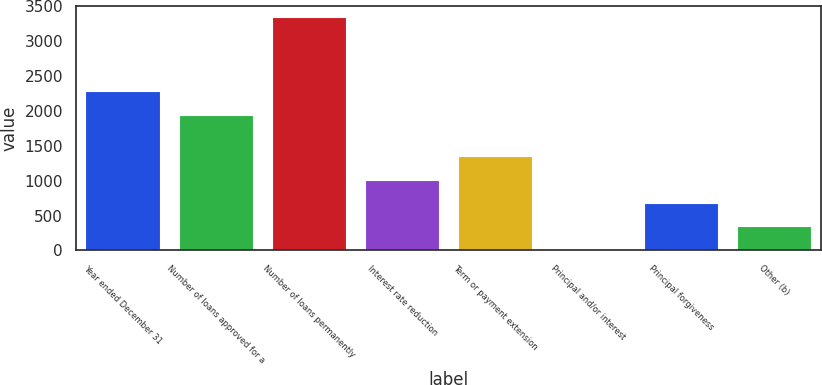<chart> <loc_0><loc_0><loc_500><loc_500><bar_chart><fcel>Year ended December 31<fcel>Number of loans approved for a<fcel>Number of loans permanently<fcel>Interest rate reduction<fcel>Term or payment extension<fcel>Principal and/or interest<fcel>Principal forgiveness<fcel>Other (b)<nl><fcel>2277.2<fcel>1945<fcel>3338<fcel>1012.6<fcel>1344.8<fcel>16<fcel>680.4<fcel>348.2<nl></chart> 